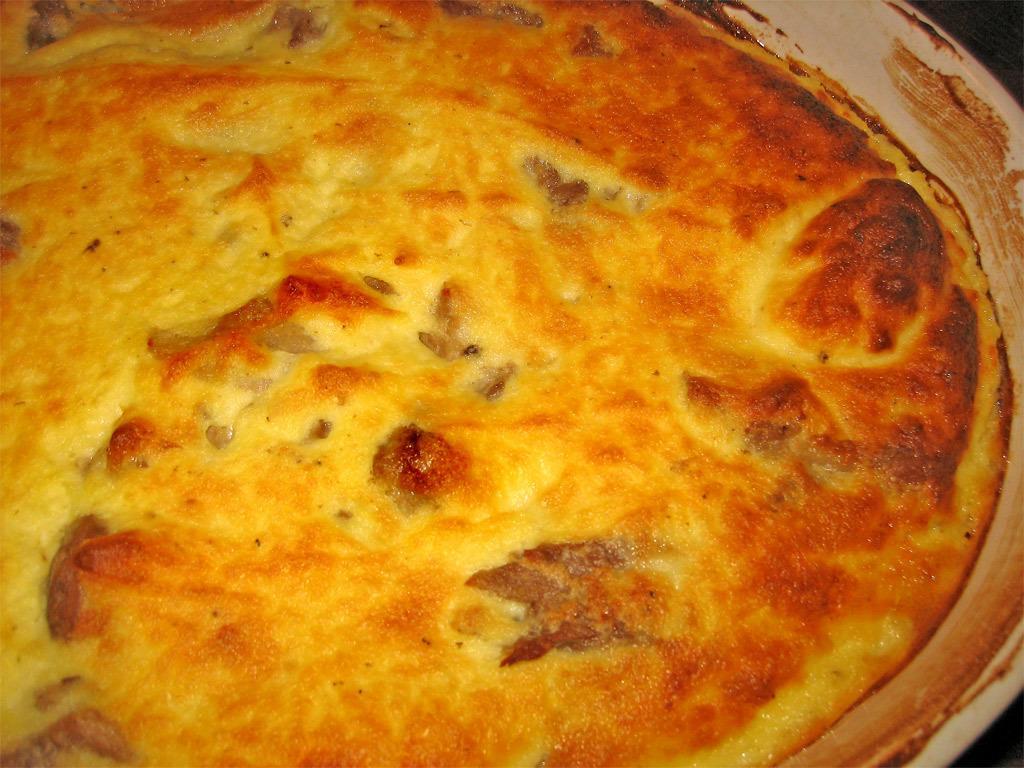In one or two sentences, can you explain what this image depicts? In this picture I can see there is some food placed in a plate and it has few vegetables in it. 